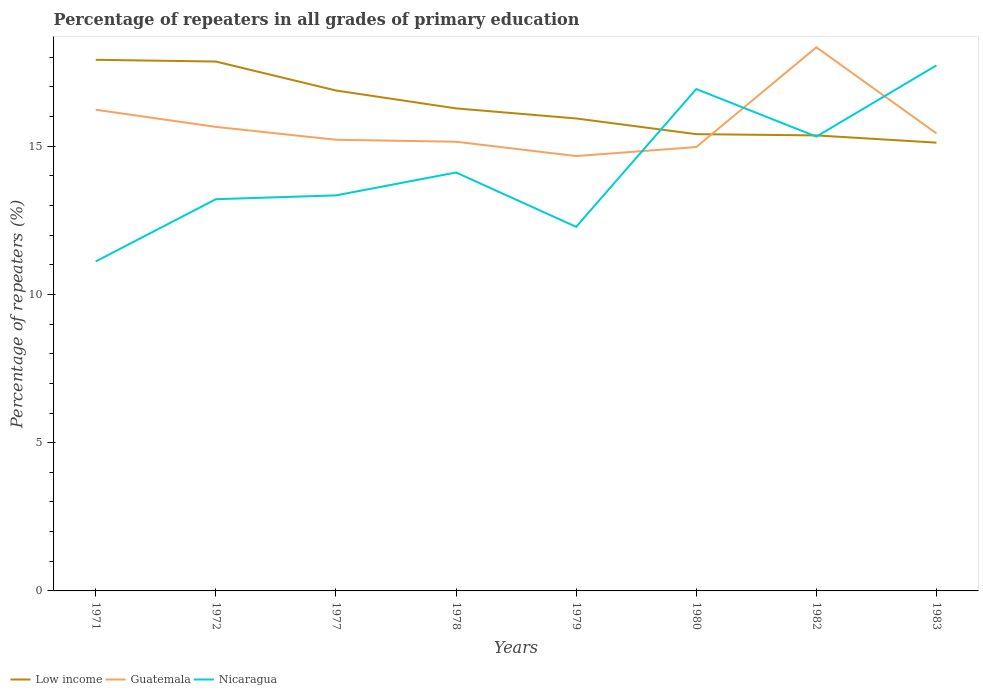Is the number of lines equal to the number of legend labels?
Give a very brief answer. Yes. Across all years, what is the maximum percentage of repeaters in Low income?
Make the answer very short. 15.12. In which year was the percentage of repeaters in Guatemala maximum?
Your answer should be compact. 1979. What is the total percentage of repeaters in Low income in the graph?
Ensure brevity in your answer.  2.51. What is the difference between the highest and the second highest percentage of repeaters in Guatemala?
Offer a very short reply. 3.67. Is the percentage of repeaters in Guatemala strictly greater than the percentage of repeaters in Nicaragua over the years?
Provide a short and direct response. No. How many years are there in the graph?
Offer a terse response. 8. What is the difference between two consecutive major ticks on the Y-axis?
Give a very brief answer. 5. Does the graph contain grids?
Offer a terse response. No. Where does the legend appear in the graph?
Keep it short and to the point. Bottom left. How many legend labels are there?
Keep it short and to the point. 3. What is the title of the graph?
Your answer should be compact. Percentage of repeaters in all grades of primary education. What is the label or title of the Y-axis?
Keep it short and to the point. Percentage of repeaters (%). What is the Percentage of repeaters (%) in Low income in 1971?
Provide a short and direct response. 17.91. What is the Percentage of repeaters (%) in Guatemala in 1971?
Make the answer very short. 16.23. What is the Percentage of repeaters (%) of Nicaragua in 1971?
Keep it short and to the point. 11.11. What is the Percentage of repeaters (%) of Low income in 1972?
Ensure brevity in your answer.  17.86. What is the Percentage of repeaters (%) in Guatemala in 1972?
Keep it short and to the point. 15.65. What is the Percentage of repeaters (%) of Nicaragua in 1972?
Provide a succinct answer. 13.21. What is the Percentage of repeaters (%) in Low income in 1977?
Your response must be concise. 16.88. What is the Percentage of repeaters (%) of Guatemala in 1977?
Your response must be concise. 15.22. What is the Percentage of repeaters (%) of Nicaragua in 1977?
Your answer should be very brief. 13.34. What is the Percentage of repeaters (%) of Low income in 1978?
Give a very brief answer. 16.27. What is the Percentage of repeaters (%) in Guatemala in 1978?
Your response must be concise. 15.15. What is the Percentage of repeaters (%) in Nicaragua in 1978?
Provide a succinct answer. 14.11. What is the Percentage of repeaters (%) in Low income in 1979?
Ensure brevity in your answer.  15.94. What is the Percentage of repeaters (%) in Guatemala in 1979?
Offer a very short reply. 14.67. What is the Percentage of repeaters (%) in Nicaragua in 1979?
Keep it short and to the point. 12.28. What is the Percentage of repeaters (%) of Low income in 1980?
Your answer should be very brief. 15.41. What is the Percentage of repeaters (%) of Guatemala in 1980?
Provide a succinct answer. 14.97. What is the Percentage of repeaters (%) of Nicaragua in 1980?
Provide a short and direct response. 16.93. What is the Percentage of repeaters (%) of Low income in 1982?
Provide a short and direct response. 15.36. What is the Percentage of repeaters (%) of Guatemala in 1982?
Your answer should be very brief. 18.34. What is the Percentage of repeaters (%) in Nicaragua in 1982?
Give a very brief answer. 15.32. What is the Percentage of repeaters (%) of Low income in 1983?
Offer a terse response. 15.12. What is the Percentage of repeaters (%) in Guatemala in 1983?
Offer a terse response. 15.43. What is the Percentage of repeaters (%) of Nicaragua in 1983?
Provide a short and direct response. 17.73. Across all years, what is the maximum Percentage of repeaters (%) in Low income?
Your response must be concise. 17.91. Across all years, what is the maximum Percentage of repeaters (%) of Guatemala?
Ensure brevity in your answer.  18.34. Across all years, what is the maximum Percentage of repeaters (%) in Nicaragua?
Give a very brief answer. 17.73. Across all years, what is the minimum Percentage of repeaters (%) of Low income?
Offer a terse response. 15.12. Across all years, what is the minimum Percentage of repeaters (%) of Guatemala?
Keep it short and to the point. 14.67. Across all years, what is the minimum Percentage of repeaters (%) of Nicaragua?
Give a very brief answer. 11.11. What is the total Percentage of repeaters (%) in Low income in the graph?
Make the answer very short. 130.75. What is the total Percentage of repeaters (%) of Guatemala in the graph?
Your answer should be very brief. 125.65. What is the total Percentage of repeaters (%) in Nicaragua in the graph?
Offer a very short reply. 114.03. What is the difference between the Percentage of repeaters (%) in Low income in 1971 and that in 1972?
Provide a succinct answer. 0.06. What is the difference between the Percentage of repeaters (%) in Guatemala in 1971 and that in 1972?
Give a very brief answer. 0.58. What is the difference between the Percentage of repeaters (%) in Nicaragua in 1971 and that in 1972?
Give a very brief answer. -2.1. What is the difference between the Percentage of repeaters (%) in Low income in 1971 and that in 1977?
Offer a terse response. 1.04. What is the difference between the Percentage of repeaters (%) of Guatemala in 1971 and that in 1977?
Provide a short and direct response. 1.01. What is the difference between the Percentage of repeaters (%) in Nicaragua in 1971 and that in 1977?
Ensure brevity in your answer.  -2.23. What is the difference between the Percentage of repeaters (%) of Low income in 1971 and that in 1978?
Your response must be concise. 1.64. What is the difference between the Percentage of repeaters (%) in Guatemala in 1971 and that in 1978?
Make the answer very short. 1.08. What is the difference between the Percentage of repeaters (%) of Nicaragua in 1971 and that in 1978?
Keep it short and to the point. -3. What is the difference between the Percentage of repeaters (%) in Low income in 1971 and that in 1979?
Offer a terse response. 1.98. What is the difference between the Percentage of repeaters (%) in Guatemala in 1971 and that in 1979?
Make the answer very short. 1.56. What is the difference between the Percentage of repeaters (%) of Nicaragua in 1971 and that in 1979?
Your response must be concise. -1.17. What is the difference between the Percentage of repeaters (%) in Low income in 1971 and that in 1980?
Your answer should be very brief. 2.51. What is the difference between the Percentage of repeaters (%) in Guatemala in 1971 and that in 1980?
Make the answer very short. 1.26. What is the difference between the Percentage of repeaters (%) in Nicaragua in 1971 and that in 1980?
Your answer should be compact. -5.82. What is the difference between the Percentage of repeaters (%) of Low income in 1971 and that in 1982?
Provide a succinct answer. 2.55. What is the difference between the Percentage of repeaters (%) of Guatemala in 1971 and that in 1982?
Make the answer very short. -2.11. What is the difference between the Percentage of repeaters (%) in Nicaragua in 1971 and that in 1982?
Provide a short and direct response. -4.21. What is the difference between the Percentage of repeaters (%) of Low income in 1971 and that in 1983?
Provide a succinct answer. 2.79. What is the difference between the Percentage of repeaters (%) of Guatemala in 1971 and that in 1983?
Your answer should be very brief. 0.8. What is the difference between the Percentage of repeaters (%) in Nicaragua in 1971 and that in 1983?
Provide a short and direct response. -6.61. What is the difference between the Percentage of repeaters (%) in Low income in 1972 and that in 1977?
Your response must be concise. 0.98. What is the difference between the Percentage of repeaters (%) in Guatemala in 1972 and that in 1977?
Your response must be concise. 0.43. What is the difference between the Percentage of repeaters (%) in Nicaragua in 1972 and that in 1977?
Make the answer very short. -0.13. What is the difference between the Percentage of repeaters (%) of Low income in 1972 and that in 1978?
Provide a succinct answer. 1.58. What is the difference between the Percentage of repeaters (%) of Guatemala in 1972 and that in 1978?
Keep it short and to the point. 0.5. What is the difference between the Percentage of repeaters (%) in Nicaragua in 1972 and that in 1978?
Your answer should be very brief. -0.9. What is the difference between the Percentage of repeaters (%) in Low income in 1972 and that in 1979?
Your answer should be very brief. 1.92. What is the difference between the Percentage of repeaters (%) in Guatemala in 1972 and that in 1979?
Keep it short and to the point. 0.98. What is the difference between the Percentage of repeaters (%) of Nicaragua in 1972 and that in 1979?
Keep it short and to the point. 0.93. What is the difference between the Percentage of repeaters (%) of Low income in 1972 and that in 1980?
Offer a very short reply. 2.45. What is the difference between the Percentage of repeaters (%) of Guatemala in 1972 and that in 1980?
Offer a very short reply. 0.68. What is the difference between the Percentage of repeaters (%) of Nicaragua in 1972 and that in 1980?
Provide a succinct answer. -3.72. What is the difference between the Percentage of repeaters (%) of Low income in 1972 and that in 1982?
Your answer should be compact. 2.49. What is the difference between the Percentage of repeaters (%) of Guatemala in 1972 and that in 1982?
Your answer should be compact. -2.69. What is the difference between the Percentage of repeaters (%) in Nicaragua in 1972 and that in 1982?
Make the answer very short. -2.11. What is the difference between the Percentage of repeaters (%) in Low income in 1972 and that in 1983?
Make the answer very short. 2.74. What is the difference between the Percentage of repeaters (%) in Guatemala in 1972 and that in 1983?
Offer a terse response. 0.22. What is the difference between the Percentage of repeaters (%) of Nicaragua in 1972 and that in 1983?
Ensure brevity in your answer.  -4.51. What is the difference between the Percentage of repeaters (%) in Low income in 1977 and that in 1978?
Offer a very short reply. 0.6. What is the difference between the Percentage of repeaters (%) of Guatemala in 1977 and that in 1978?
Provide a succinct answer. 0.07. What is the difference between the Percentage of repeaters (%) in Nicaragua in 1977 and that in 1978?
Give a very brief answer. -0.77. What is the difference between the Percentage of repeaters (%) of Low income in 1977 and that in 1979?
Offer a terse response. 0.94. What is the difference between the Percentage of repeaters (%) of Guatemala in 1977 and that in 1979?
Your response must be concise. 0.55. What is the difference between the Percentage of repeaters (%) of Nicaragua in 1977 and that in 1979?
Keep it short and to the point. 1.06. What is the difference between the Percentage of repeaters (%) of Low income in 1977 and that in 1980?
Provide a succinct answer. 1.47. What is the difference between the Percentage of repeaters (%) of Guatemala in 1977 and that in 1980?
Your answer should be very brief. 0.25. What is the difference between the Percentage of repeaters (%) of Nicaragua in 1977 and that in 1980?
Your answer should be compact. -3.59. What is the difference between the Percentage of repeaters (%) in Low income in 1977 and that in 1982?
Keep it short and to the point. 1.51. What is the difference between the Percentage of repeaters (%) in Guatemala in 1977 and that in 1982?
Your answer should be very brief. -3.12. What is the difference between the Percentage of repeaters (%) in Nicaragua in 1977 and that in 1982?
Ensure brevity in your answer.  -1.98. What is the difference between the Percentage of repeaters (%) in Low income in 1977 and that in 1983?
Your answer should be very brief. 1.76. What is the difference between the Percentage of repeaters (%) in Guatemala in 1977 and that in 1983?
Your answer should be very brief. -0.21. What is the difference between the Percentage of repeaters (%) of Nicaragua in 1977 and that in 1983?
Your response must be concise. -4.38. What is the difference between the Percentage of repeaters (%) of Low income in 1978 and that in 1979?
Provide a short and direct response. 0.34. What is the difference between the Percentage of repeaters (%) in Guatemala in 1978 and that in 1979?
Make the answer very short. 0.48. What is the difference between the Percentage of repeaters (%) in Nicaragua in 1978 and that in 1979?
Ensure brevity in your answer.  1.83. What is the difference between the Percentage of repeaters (%) of Low income in 1978 and that in 1980?
Keep it short and to the point. 0.87. What is the difference between the Percentage of repeaters (%) of Guatemala in 1978 and that in 1980?
Your response must be concise. 0.18. What is the difference between the Percentage of repeaters (%) in Nicaragua in 1978 and that in 1980?
Keep it short and to the point. -2.82. What is the difference between the Percentage of repeaters (%) in Low income in 1978 and that in 1982?
Keep it short and to the point. 0.91. What is the difference between the Percentage of repeaters (%) in Guatemala in 1978 and that in 1982?
Provide a short and direct response. -3.19. What is the difference between the Percentage of repeaters (%) of Nicaragua in 1978 and that in 1982?
Keep it short and to the point. -1.21. What is the difference between the Percentage of repeaters (%) of Low income in 1978 and that in 1983?
Make the answer very short. 1.16. What is the difference between the Percentage of repeaters (%) in Guatemala in 1978 and that in 1983?
Make the answer very short. -0.28. What is the difference between the Percentage of repeaters (%) of Nicaragua in 1978 and that in 1983?
Offer a very short reply. -3.61. What is the difference between the Percentage of repeaters (%) of Low income in 1979 and that in 1980?
Keep it short and to the point. 0.53. What is the difference between the Percentage of repeaters (%) of Guatemala in 1979 and that in 1980?
Provide a short and direct response. -0.3. What is the difference between the Percentage of repeaters (%) in Nicaragua in 1979 and that in 1980?
Offer a terse response. -4.65. What is the difference between the Percentage of repeaters (%) of Guatemala in 1979 and that in 1982?
Your answer should be compact. -3.67. What is the difference between the Percentage of repeaters (%) of Nicaragua in 1979 and that in 1982?
Your answer should be very brief. -3.04. What is the difference between the Percentage of repeaters (%) in Low income in 1979 and that in 1983?
Your response must be concise. 0.82. What is the difference between the Percentage of repeaters (%) of Guatemala in 1979 and that in 1983?
Offer a terse response. -0.76. What is the difference between the Percentage of repeaters (%) in Nicaragua in 1979 and that in 1983?
Keep it short and to the point. -5.45. What is the difference between the Percentage of repeaters (%) of Low income in 1980 and that in 1982?
Offer a very short reply. 0.04. What is the difference between the Percentage of repeaters (%) of Guatemala in 1980 and that in 1982?
Make the answer very short. -3.36. What is the difference between the Percentage of repeaters (%) of Nicaragua in 1980 and that in 1982?
Give a very brief answer. 1.6. What is the difference between the Percentage of repeaters (%) of Low income in 1980 and that in 1983?
Make the answer very short. 0.29. What is the difference between the Percentage of repeaters (%) of Guatemala in 1980 and that in 1983?
Provide a short and direct response. -0.46. What is the difference between the Percentage of repeaters (%) in Nicaragua in 1980 and that in 1983?
Make the answer very short. -0.8. What is the difference between the Percentage of repeaters (%) of Low income in 1982 and that in 1983?
Your answer should be compact. 0.24. What is the difference between the Percentage of repeaters (%) of Guatemala in 1982 and that in 1983?
Ensure brevity in your answer.  2.9. What is the difference between the Percentage of repeaters (%) in Nicaragua in 1982 and that in 1983?
Your answer should be very brief. -2.4. What is the difference between the Percentage of repeaters (%) in Low income in 1971 and the Percentage of repeaters (%) in Guatemala in 1972?
Offer a very short reply. 2.26. What is the difference between the Percentage of repeaters (%) in Low income in 1971 and the Percentage of repeaters (%) in Nicaragua in 1972?
Keep it short and to the point. 4.7. What is the difference between the Percentage of repeaters (%) of Guatemala in 1971 and the Percentage of repeaters (%) of Nicaragua in 1972?
Offer a terse response. 3.02. What is the difference between the Percentage of repeaters (%) in Low income in 1971 and the Percentage of repeaters (%) in Guatemala in 1977?
Ensure brevity in your answer.  2.7. What is the difference between the Percentage of repeaters (%) in Low income in 1971 and the Percentage of repeaters (%) in Nicaragua in 1977?
Offer a terse response. 4.57. What is the difference between the Percentage of repeaters (%) in Guatemala in 1971 and the Percentage of repeaters (%) in Nicaragua in 1977?
Your response must be concise. 2.89. What is the difference between the Percentage of repeaters (%) in Low income in 1971 and the Percentage of repeaters (%) in Guatemala in 1978?
Ensure brevity in your answer.  2.76. What is the difference between the Percentage of repeaters (%) of Low income in 1971 and the Percentage of repeaters (%) of Nicaragua in 1978?
Offer a very short reply. 3.8. What is the difference between the Percentage of repeaters (%) in Guatemala in 1971 and the Percentage of repeaters (%) in Nicaragua in 1978?
Your answer should be very brief. 2.12. What is the difference between the Percentage of repeaters (%) in Low income in 1971 and the Percentage of repeaters (%) in Guatemala in 1979?
Your answer should be very brief. 3.25. What is the difference between the Percentage of repeaters (%) of Low income in 1971 and the Percentage of repeaters (%) of Nicaragua in 1979?
Your response must be concise. 5.63. What is the difference between the Percentage of repeaters (%) of Guatemala in 1971 and the Percentage of repeaters (%) of Nicaragua in 1979?
Give a very brief answer. 3.95. What is the difference between the Percentage of repeaters (%) of Low income in 1971 and the Percentage of repeaters (%) of Guatemala in 1980?
Your answer should be very brief. 2.94. What is the difference between the Percentage of repeaters (%) of Low income in 1971 and the Percentage of repeaters (%) of Nicaragua in 1980?
Provide a succinct answer. 0.99. What is the difference between the Percentage of repeaters (%) in Guatemala in 1971 and the Percentage of repeaters (%) in Nicaragua in 1980?
Keep it short and to the point. -0.7. What is the difference between the Percentage of repeaters (%) in Low income in 1971 and the Percentage of repeaters (%) in Guatemala in 1982?
Make the answer very short. -0.42. What is the difference between the Percentage of repeaters (%) in Low income in 1971 and the Percentage of repeaters (%) in Nicaragua in 1982?
Your answer should be very brief. 2.59. What is the difference between the Percentage of repeaters (%) of Guatemala in 1971 and the Percentage of repeaters (%) of Nicaragua in 1982?
Provide a succinct answer. 0.91. What is the difference between the Percentage of repeaters (%) in Low income in 1971 and the Percentage of repeaters (%) in Guatemala in 1983?
Offer a very short reply. 2.48. What is the difference between the Percentage of repeaters (%) of Low income in 1971 and the Percentage of repeaters (%) of Nicaragua in 1983?
Your answer should be compact. 0.19. What is the difference between the Percentage of repeaters (%) of Guatemala in 1971 and the Percentage of repeaters (%) of Nicaragua in 1983?
Ensure brevity in your answer.  -1.5. What is the difference between the Percentage of repeaters (%) of Low income in 1972 and the Percentage of repeaters (%) of Guatemala in 1977?
Provide a succinct answer. 2.64. What is the difference between the Percentage of repeaters (%) in Low income in 1972 and the Percentage of repeaters (%) in Nicaragua in 1977?
Your answer should be compact. 4.51. What is the difference between the Percentage of repeaters (%) of Guatemala in 1972 and the Percentage of repeaters (%) of Nicaragua in 1977?
Ensure brevity in your answer.  2.31. What is the difference between the Percentage of repeaters (%) in Low income in 1972 and the Percentage of repeaters (%) in Guatemala in 1978?
Your answer should be very brief. 2.7. What is the difference between the Percentage of repeaters (%) in Low income in 1972 and the Percentage of repeaters (%) in Nicaragua in 1978?
Provide a short and direct response. 3.74. What is the difference between the Percentage of repeaters (%) of Guatemala in 1972 and the Percentage of repeaters (%) of Nicaragua in 1978?
Offer a terse response. 1.54. What is the difference between the Percentage of repeaters (%) of Low income in 1972 and the Percentage of repeaters (%) of Guatemala in 1979?
Offer a terse response. 3.19. What is the difference between the Percentage of repeaters (%) of Low income in 1972 and the Percentage of repeaters (%) of Nicaragua in 1979?
Offer a very short reply. 5.58. What is the difference between the Percentage of repeaters (%) of Guatemala in 1972 and the Percentage of repeaters (%) of Nicaragua in 1979?
Give a very brief answer. 3.37. What is the difference between the Percentage of repeaters (%) in Low income in 1972 and the Percentage of repeaters (%) in Guatemala in 1980?
Provide a succinct answer. 2.88. What is the difference between the Percentage of repeaters (%) in Low income in 1972 and the Percentage of repeaters (%) in Nicaragua in 1980?
Your response must be concise. 0.93. What is the difference between the Percentage of repeaters (%) of Guatemala in 1972 and the Percentage of repeaters (%) of Nicaragua in 1980?
Your answer should be very brief. -1.28. What is the difference between the Percentage of repeaters (%) in Low income in 1972 and the Percentage of repeaters (%) in Guatemala in 1982?
Your response must be concise. -0.48. What is the difference between the Percentage of repeaters (%) of Low income in 1972 and the Percentage of repeaters (%) of Nicaragua in 1982?
Make the answer very short. 2.53. What is the difference between the Percentage of repeaters (%) of Guatemala in 1972 and the Percentage of repeaters (%) of Nicaragua in 1982?
Provide a short and direct response. 0.33. What is the difference between the Percentage of repeaters (%) of Low income in 1972 and the Percentage of repeaters (%) of Guatemala in 1983?
Ensure brevity in your answer.  2.42. What is the difference between the Percentage of repeaters (%) in Low income in 1972 and the Percentage of repeaters (%) in Nicaragua in 1983?
Your answer should be very brief. 0.13. What is the difference between the Percentage of repeaters (%) in Guatemala in 1972 and the Percentage of repeaters (%) in Nicaragua in 1983?
Your response must be concise. -2.08. What is the difference between the Percentage of repeaters (%) in Low income in 1977 and the Percentage of repeaters (%) in Guatemala in 1978?
Provide a succinct answer. 1.73. What is the difference between the Percentage of repeaters (%) of Low income in 1977 and the Percentage of repeaters (%) of Nicaragua in 1978?
Keep it short and to the point. 2.77. What is the difference between the Percentage of repeaters (%) of Guatemala in 1977 and the Percentage of repeaters (%) of Nicaragua in 1978?
Your answer should be compact. 1.1. What is the difference between the Percentage of repeaters (%) of Low income in 1977 and the Percentage of repeaters (%) of Guatemala in 1979?
Give a very brief answer. 2.21. What is the difference between the Percentage of repeaters (%) in Low income in 1977 and the Percentage of repeaters (%) in Nicaragua in 1979?
Your answer should be compact. 4.6. What is the difference between the Percentage of repeaters (%) in Guatemala in 1977 and the Percentage of repeaters (%) in Nicaragua in 1979?
Provide a succinct answer. 2.94. What is the difference between the Percentage of repeaters (%) of Low income in 1977 and the Percentage of repeaters (%) of Guatemala in 1980?
Your answer should be compact. 1.91. What is the difference between the Percentage of repeaters (%) of Low income in 1977 and the Percentage of repeaters (%) of Nicaragua in 1980?
Ensure brevity in your answer.  -0.05. What is the difference between the Percentage of repeaters (%) of Guatemala in 1977 and the Percentage of repeaters (%) of Nicaragua in 1980?
Offer a terse response. -1.71. What is the difference between the Percentage of repeaters (%) in Low income in 1977 and the Percentage of repeaters (%) in Guatemala in 1982?
Your answer should be very brief. -1.46. What is the difference between the Percentage of repeaters (%) in Low income in 1977 and the Percentage of repeaters (%) in Nicaragua in 1982?
Give a very brief answer. 1.55. What is the difference between the Percentage of repeaters (%) of Guatemala in 1977 and the Percentage of repeaters (%) of Nicaragua in 1982?
Offer a very short reply. -0.11. What is the difference between the Percentage of repeaters (%) in Low income in 1977 and the Percentage of repeaters (%) in Guatemala in 1983?
Your response must be concise. 1.45. What is the difference between the Percentage of repeaters (%) in Low income in 1977 and the Percentage of repeaters (%) in Nicaragua in 1983?
Provide a succinct answer. -0.85. What is the difference between the Percentage of repeaters (%) in Guatemala in 1977 and the Percentage of repeaters (%) in Nicaragua in 1983?
Provide a succinct answer. -2.51. What is the difference between the Percentage of repeaters (%) of Low income in 1978 and the Percentage of repeaters (%) of Guatemala in 1979?
Offer a terse response. 1.61. What is the difference between the Percentage of repeaters (%) of Low income in 1978 and the Percentage of repeaters (%) of Nicaragua in 1979?
Offer a terse response. 3.99. What is the difference between the Percentage of repeaters (%) of Guatemala in 1978 and the Percentage of repeaters (%) of Nicaragua in 1979?
Your answer should be compact. 2.87. What is the difference between the Percentage of repeaters (%) in Low income in 1978 and the Percentage of repeaters (%) in Guatemala in 1980?
Provide a succinct answer. 1.3. What is the difference between the Percentage of repeaters (%) of Low income in 1978 and the Percentage of repeaters (%) of Nicaragua in 1980?
Keep it short and to the point. -0.65. What is the difference between the Percentage of repeaters (%) in Guatemala in 1978 and the Percentage of repeaters (%) in Nicaragua in 1980?
Offer a very short reply. -1.78. What is the difference between the Percentage of repeaters (%) of Low income in 1978 and the Percentage of repeaters (%) of Guatemala in 1982?
Make the answer very short. -2.06. What is the difference between the Percentage of repeaters (%) of Low income in 1978 and the Percentage of repeaters (%) of Nicaragua in 1982?
Keep it short and to the point. 0.95. What is the difference between the Percentage of repeaters (%) of Guatemala in 1978 and the Percentage of repeaters (%) of Nicaragua in 1982?
Your response must be concise. -0.17. What is the difference between the Percentage of repeaters (%) of Low income in 1978 and the Percentage of repeaters (%) of Guatemala in 1983?
Your response must be concise. 0.84. What is the difference between the Percentage of repeaters (%) of Low income in 1978 and the Percentage of repeaters (%) of Nicaragua in 1983?
Keep it short and to the point. -1.45. What is the difference between the Percentage of repeaters (%) in Guatemala in 1978 and the Percentage of repeaters (%) in Nicaragua in 1983?
Give a very brief answer. -2.58. What is the difference between the Percentage of repeaters (%) of Low income in 1979 and the Percentage of repeaters (%) of Guatemala in 1980?
Make the answer very short. 0.96. What is the difference between the Percentage of repeaters (%) in Low income in 1979 and the Percentage of repeaters (%) in Nicaragua in 1980?
Give a very brief answer. -0.99. What is the difference between the Percentage of repeaters (%) in Guatemala in 1979 and the Percentage of repeaters (%) in Nicaragua in 1980?
Give a very brief answer. -2.26. What is the difference between the Percentage of repeaters (%) of Low income in 1979 and the Percentage of repeaters (%) of Guatemala in 1982?
Keep it short and to the point. -2.4. What is the difference between the Percentage of repeaters (%) in Low income in 1979 and the Percentage of repeaters (%) in Nicaragua in 1982?
Provide a short and direct response. 0.61. What is the difference between the Percentage of repeaters (%) in Guatemala in 1979 and the Percentage of repeaters (%) in Nicaragua in 1982?
Your answer should be very brief. -0.66. What is the difference between the Percentage of repeaters (%) of Low income in 1979 and the Percentage of repeaters (%) of Guatemala in 1983?
Provide a succinct answer. 0.5. What is the difference between the Percentage of repeaters (%) in Low income in 1979 and the Percentage of repeaters (%) in Nicaragua in 1983?
Provide a succinct answer. -1.79. What is the difference between the Percentage of repeaters (%) in Guatemala in 1979 and the Percentage of repeaters (%) in Nicaragua in 1983?
Ensure brevity in your answer.  -3.06. What is the difference between the Percentage of repeaters (%) of Low income in 1980 and the Percentage of repeaters (%) of Guatemala in 1982?
Ensure brevity in your answer.  -2.93. What is the difference between the Percentage of repeaters (%) in Low income in 1980 and the Percentage of repeaters (%) in Nicaragua in 1982?
Provide a short and direct response. 0.08. What is the difference between the Percentage of repeaters (%) of Guatemala in 1980 and the Percentage of repeaters (%) of Nicaragua in 1982?
Provide a short and direct response. -0.35. What is the difference between the Percentage of repeaters (%) of Low income in 1980 and the Percentage of repeaters (%) of Guatemala in 1983?
Ensure brevity in your answer.  -0.03. What is the difference between the Percentage of repeaters (%) in Low income in 1980 and the Percentage of repeaters (%) in Nicaragua in 1983?
Your answer should be compact. -2.32. What is the difference between the Percentage of repeaters (%) in Guatemala in 1980 and the Percentage of repeaters (%) in Nicaragua in 1983?
Your answer should be very brief. -2.75. What is the difference between the Percentage of repeaters (%) of Low income in 1982 and the Percentage of repeaters (%) of Guatemala in 1983?
Offer a very short reply. -0.07. What is the difference between the Percentage of repeaters (%) of Low income in 1982 and the Percentage of repeaters (%) of Nicaragua in 1983?
Make the answer very short. -2.36. What is the difference between the Percentage of repeaters (%) in Guatemala in 1982 and the Percentage of repeaters (%) in Nicaragua in 1983?
Ensure brevity in your answer.  0.61. What is the average Percentage of repeaters (%) of Low income per year?
Your response must be concise. 16.34. What is the average Percentage of repeaters (%) of Guatemala per year?
Offer a terse response. 15.71. What is the average Percentage of repeaters (%) of Nicaragua per year?
Give a very brief answer. 14.25. In the year 1971, what is the difference between the Percentage of repeaters (%) in Low income and Percentage of repeaters (%) in Guatemala?
Offer a terse response. 1.68. In the year 1971, what is the difference between the Percentage of repeaters (%) in Low income and Percentage of repeaters (%) in Nicaragua?
Offer a terse response. 6.8. In the year 1971, what is the difference between the Percentage of repeaters (%) of Guatemala and Percentage of repeaters (%) of Nicaragua?
Provide a succinct answer. 5.12. In the year 1972, what is the difference between the Percentage of repeaters (%) of Low income and Percentage of repeaters (%) of Guatemala?
Keep it short and to the point. 2.2. In the year 1972, what is the difference between the Percentage of repeaters (%) of Low income and Percentage of repeaters (%) of Nicaragua?
Offer a very short reply. 4.64. In the year 1972, what is the difference between the Percentage of repeaters (%) in Guatemala and Percentage of repeaters (%) in Nicaragua?
Offer a terse response. 2.44. In the year 1977, what is the difference between the Percentage of repeaters (%) of Low income and Percentage of repeaters (%) of Guatemala?
Make the answer very short. 1.66. In the year 1977, what is the difference between the Percentage of repeaters (%) in Low income and Percentage of repeaters (%) in Nicaragua?
Offer a terse response. 3.54. In the year 1977, what is the difference between the Percentage of repeaters (%) of Guatemala and Percentage of repeaters (%) of Nicaragua?
Your answer should be very brief. 1.88. In the year 1978, what is the difference between the Percentage of repeaters (%) of Low income and Percentage of repeaters (%) of Guatemala?
Offer a very short reply. 1.12. In the year 1978, what is the difference between the Percentage of repeaters (%) of Low income and Percentage of repeaters (%) of Nicaragua?
Provide a succinct answer. 2.16. In the year 1978, what is the difference between the Percentage of repeaters (%) of Guatemala and Percentage of repeaters (%) of Nicaragua?
Give a very brief answer. 1.04. In the year 1979, what is the difference between the Percentage of repeaters (%) of Low income and Percentage of repeaters (%) of Guatemala?
Give a very brief answer. 1.27. In the year 1979, what is the difference between the Percentage of repeaters (%) of Low income and Percentage of repeaters (%) of Nicaragua?
Make the answer very short. 3.66. In the year 1979, what is the difference between the Percentage of repeaters (%) in Guatemala and Percentage of repeaters (%) in Nicaragua?
Make the answer very short. 2.39. In the year 1980, what is the difference between the Percentage of repeaters (%) in Low income and Percentage of repeaters (%) in Guatemala?
Ensure brevity in your answer.  0.43. In the year 1980, what is the difference between the Percentage of repeaters (%) in Low income and Percentage of repeaters (%) in Nicaragua?
Provide a short and direct response. -1.52. In the year 1980, what is the difference between the Percentage of repeaters (%) of Guatemala and Percentage of repeaters (%) of Nicaragua?
Your answer should be compact. -1.96. In the year 1982, what is the difference between the Percentage of repeaters (%) of Low income and Percentage of repeaters (%) of Guatemala?
Keep it short and to the point. -2.97. In the year 1982, what is the difference between the Percentage of repeaters (%) of Low income and Percentage of repeaters (%) of Nicaragua?
Ensure brevity in your answer.  0.04. In the year 1982, what is the difference between the Percentage of repeaters (%) of Guatemala and Percentage of repeaters (%) of Nicaragua?
Your answer should be very brief. 3.01. In the year 1983, what is the difference between the Percentage of repeaters (%) in Low income and Percentage of repeaters (%) in Guatemala?
Offer a terse response. -0.31. In the year 1983, what is the difference between the Percentage of repeaters (%) of Low income and Percentage of repeaters (%) of Nicaragua?
Your response must be concise. -2.61. In the year 1983, what is the difference between the Percentage of repeaters (%) in Guatemala and Percentage of repeaters (%) in Nicaragua?
Offer a very short reply. -2.29. What is the ratio of the Percentage of repeaters (%) of Guatemala in 1971 to that in 1972?
Provide a short and direct response. 1.04. What is the ratio of the Percentage of repeaters (%) of Nicaragua in 1971 to that in 1972?
Provide a succinct answer. 0.84. What is the ratio of the Percentage of repeaters (%) in Low income in 1971 to that in 1977?
Give a very brief answer. 1.06. What is the ratio of the Percentage of repeaters (%) of Guatemala in 1971 to that in 1977?
Ensure brevity in your answer.  1.07. What is the ratio of the Percentage of repeaters (%) in Nicaragua in 1971 to that in 1977?
Provide a succinct answer. 0.83. What is the ratio of the Percentage of repeaters (%) in Low income in 1971 to that in 1978?
Offer a very short reply. 1.1. What is the ratio of the Percentage of repeaters (%) of Guatemala in 1971 to that in 1978?
Ensure brevity in your answer.  1.07. What is the ratio of the Percentage of repeaters (%) of Nicaragua in 1971 to that in 1978?
Keep it short and to the point. 0.79. What is the ratio of the Percentage of repeaters (%) in Low income in 1971 to that in 1979?
Offer a terse response. 1.12. What is the ratio of the Percentage of repeaters (%) in Guatemala in 1971 to that in 1979?
Provide a short and direct response. 1.11. What is the ratio of the Percentage of repeaters (%) in Nicaragua in 1971 to that in 1979?
Ensure brevity in your answer.  0.9. What is the ratio of the Percentage of repeaters (%) of Low income in 1971 to that in 1980?
Keep it short and to the point. 1.16. What is the ratio of the Percentage of repeaters (%) in Guatemala in 1971 to that in 1980?
Your answer should be very brief. 1.08. What is the ratio of the Percentage of repeaters (%) of Nicaragua in 1971 to that in 1980?
Provide a short and direct response. 0.66. What is the ratio of the Percentage of repeaters (%) of Low income in 1971 to that in 1982?
Your response must be concise. 1.17. What is the ratio of the Percentage of repeaters (%) of Guatemala in 1971 to that in 1982?
Make the answer very short. 0.89. What is the ratio of the Percentage of repeaters (%) in Nicaragua in 1971 to that in 1982?
Ensure brevity in your answer.  0.73. What is the ratio of the Percentage of repeaters (%) in Low income in 1971 to that in 1983?
Provide a short and direct response. 1.18. What is the ratio of the Percentage of repeaters (%) of Guatemala in 1971 to that in 1983?
Your answer should be compact. 1.05. What is the ratio of the Percentage of repeaters (%) in Nicaragua in 1971 to that in 1983?
Provide a short and direct response. 0.63. What is the ratio of the Percentage of repeaters (%) in Low income in 1972 to that in 1977?
Keep it short and to the point. 1.06. What is the ratio of the Percentage of repeaters (%) in Guatemala in 1972 to that in 1977?
Keep it short and to the point. 1.03. What is the ratio of the Percentage of repeaters (%) in Nicaragua in 1972 to that in 1977?
Provide a short and direct response. 0.99. What is the ratio of the Percentage of repeaters (%) of Low income in 1972 to that in 1978?
Offer a terse response. 1.1. What is the ratio of the Percentage of repeaters (%) in Guatemala in 1972 to that in 1978?
Give a very brief answer. 1.03. What is the ratio of the Percentage of repeaters (%) in Nicaragua in 1972 to that in 1978?
Provide a short and direct response. 0.94. What is the ratio of the Percentage of repeaters (%) in Low income in 1972 to that in 1979?
Make the answer very short. 1.12. What is the ratio of the Percentage of repeaters (%) of Guatemala in 1972 to that in 1979?
Make the answer very short. 1.07. What is the ratio of the Percentage of repeaters (%) of Nicaragua in 1972 to that in 1979?
Keep it short and to the point. 1.08. What is the ratio of the Percentage of repeaters (%) in Low income in 1972 to that in 1980?
Ensure brevity in your answer.  1.16. What is the ratio of the Percentage of repeaters (%) in Guatemala in 1972 to that in 1980?
Offer a very short reply. 1.05. What is the ratio of the Percentage of repeaters (%) of Nicaragua in 1972 to that in 1980?
Offer a terse response. 0.78. What is the ratio of the Percentage of repeaters (%) in Low income in 1972 to that in 1982?
Offer a very short reply. 1.16. What is the ratio of the Percentage of repeaters (%) of Guatemala in 1972 to that in 1982?
Offer a very short reply. 0.85. What is the ratio of the Percentage of repeaters (%) of Nicaragua in 1972 to that in 1982?
Your response must be concise. 0.86. What is the ratio of the Percentage of repeaters (%) in Low income in 1972 to that in 1983?
Keep it short and to the point. 1.18. What is the ratio of the Percentage of repeaters (%) of Guatemala in 1972 to that in 1983?
Ensure brevity in your answer.  1.01. What is the ratio of the Percentage of repeaters (%) of Nicaragua in 1972 to that in 1983?
Provide a short and direct response. 0.75. What is the ratio of the Percentage of repeaters (%) in Low income in 1977 to that in 1978?
Your answer should be compact. 1.04. What is the ratio of the Percentage of repeaters (%) in Nicaragua in 1977 to that in 1978?
Give a very brief answer. 0.95. What is the ratio of the Percentage of repeaters (%) in Low income in 1977 to that in 1979?
Your answer should be compact. 1.06. What is the ratio of the Percentage of repeaters (%) in Guatemala in 1977 to that in 1979?
Keep it short and to the point. 1.04. What is the ratio of the Percentage of repeaters (%) of Nicaragua in 1977 to that in 1979?
Offer a very short reply. 1.09. What is the ratio of the Percentage of repeaters (%) in Low income in 1977 to that in 1980?
Give a very brief answer. 1.1. What is the ratio of the Percentage of repeaters (%) in Guatemala in 1977 to that in 1980?
Keep it short and to the point. 1.02. What is the ratio of the Percentage of repeaters (%) of Nicaragua in 1977 to that in 1980?
Ensure brevity in your answer.  0.79. What is the ratio of the Percentage of repeaters (%) in Low income in 1977 to that in 1982?
Your response must be concise. 1.1. What is the ratio of the Percentage of repeaters (%) in Guatemala in 1977 to that in 1982?
Offer a terse response. 0.83. What is the ratio of the Percentage of repeaters (%) of Nicaragua in 1977 to that in 1982?
Offer a very short reply. 0.87. What is the ratio of the Percentage of repeaters (%) of Low income in 1977 to that in 1983?
Offer a very short reply. 1.12. What is the ratio of the Percentage of repeaters (%) in Guatemala in 1977 to that in 1983?
Give a very brief answer. 0.99. What is the ratio of the Percentage of repeaters (%) in Nicaragua in 1977 to that in 1983?
Ensure brevity in your answer.  0.75. What is the ratio of the Percentage of repeaters (%) in Low income in 1978 to that in 1979?
Offer a very short reply. 1.02. What is the ratio of the Percentage of repeaters (%) in Guatemala in 1978 to that in 1979?
Offer a terse response. 1.03. What is the ratio of the Percentage of repeaters (%) of Nicaragua in 1978 to that in 1979?
Ensure brevity in your answer.  1.15. What is the ratio of the Percentage of repeaters (%) in Low income in 1978 to that in 1980?
Provide a succinct answer. 1.06. What is the ratio of the Percentage of repeaters (%) of Guatemala in 1978 to that in 1980?
Your answer should be compact. 1.01. What is the ratio of the Percentage of repeaters (%) in Nicaragua in 1978 to that in 1980?
Keep it short and to the point. 0.83. What is the ratio of the Percentage of repeaters (%) in Low income in 1978 to that in 1982?
Your response must be concise. 1.06. What is the ratio of the Percentage of repeaters (%) of Guatemala in 1978 to that in 1982?
Offer a terse response. 0.83. What is the ratio of the Percentage of repeaters (%) in Nicaragua in 1978 to that in 1982?
Your answer should be very brief. 0.92. What is the ratio of the Percentage of repeaters (%) of Low income in 1978 to that in 1983?
Your answer should be very brief. 1.08. What is the ratio of the Percentage of repeaters (%) in Guatemala in 1978 to that in 1983?
Your answer should be very brief. 0.98. What is the ratio of the Percentage of repeaters (%) of Nicaragua in 1978 to that in 1983?
Your response must be concise. 0.8. What is the ratio of the Percentage of repeaters (%) in Low income in 1979 to that in 1980?
Offer a very short reply. 1.03. What is the ratio of the Percentage of repeaters (%) of Guatemala in 1979 to that in 1980?
Make the answer very short. 0.98. What is the ratio of the Percentage of repeaters (%) in Nicaragua in 1979 to that in 1980?
Provide a succinct answer. 0.73. What is the ratio of the Percentage of repeaters (%) in Low income in 1979 to that in 1982?
Provide a short and direct response. 1.04. What is the ratio of the Percentage of repeaters (%) in Guatemala in 1979 to that in 1982?
Provide a short and direct response. 0.8. What is the ratio of the Percentage of repeaters (%) of Nicaragua in 1979 to that in 1982?
Give a very brief answer. 0.8. What is the ratio of the Percentage of repeaters (%) of Low income in 1979 to that in 1983?
Ensure brevity in your answer.  1.05. What is the ratio of the Percentage of repeaters (%) in Guatemala in 1979 to that in 1983?
Keep it short and to the point. 0.95. What is the ratio of the Percentage of repeaters (%) of Nicaragua in 1979 to that in 1983?
Make the answer very short. 0.69. What is the ratio of the Percentage of repeaters (%) in Low income in 1980 to that in 1982?
Ensure brevity in your answer.  1. What is the ratio of the Percentage of repeaters (%) in Guatemala in 1980 to that in 1982?
Offer a terse response. 0.82. What is the ratio of the Percentage of repeaters (%) in Nicaragua in 1980 to that in 1982?
Your response must be concise. 1.1. What is the ratio of the Percentage of repeaters (%) of Low income in 1980 to that in 1983?
Your answer should be compact. 1.02. What is the ratio of the Percentage of repeaters (%) in Guatemala in 1980 to that in 1983?
Your answer should be very brief. 0.97. What is the ratio of the Percentage of repeaters (%) in Nicaragua in 1980 to that in 1983?
Your response must be concise. 0.95. What is the ratio of the Percentage of repeaters (%) of Low income in 1982 to that in 1983?
Your answer should be very brief. 1.02. What is the ratio of the Percentage of repeaters (%) in Guatemala in 1982 to that in 1983?
Offer a very short reply. 1.19. What is the ratio of the Percentage of repeaters (%) of Nicaragua in 1982 to that in 1983?
Give a very brief answer. 0.86. What is the difference between the highest and the second highest Percentage of repeaters (%) in Low income?
Provide a short and direct response. 0.06. What is the difference between the highest and the second highest Percentage of repeaters (%) in Guatemala?
Keep it short and to the point. 2.11. What is the difference between the highest and the second highest Percentage of repeaters (%) of Nicaragua?
Your answer should be very brief. 0.8. What is the difference between the highest and the lowest Percentage of repeaters (%) of Low income?
Provide a short and direct response. 2.79. What is the difference between the highest and the lowest Percentage of repeaters (%) in Guatemala?
Your answer should be very brief. 3.67. What is the difference between the highest and the lowest Percentage of repeaters (%) in Nicaragua?
Give a very brief answer. 6.61. 